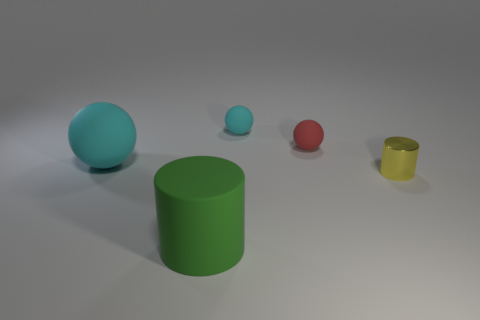Subtract all purple balls. Subtract all yellow blocks. How many balls are left? 3 Add 4 big purple objects. How many objects exist? 9 Subtract all spheres. How many objects are left? 2 Subtract 0 cyan cylinders. How many objects are left? 5 Subtract all small gray matte cubes. Subtract all small red rubber spheres. How many objects are left? 4 Add 1 large green rubber things. How many large green rubber things are left? 2 Add 2 metallic cylinders. How many metallic cylinders exist? 3 